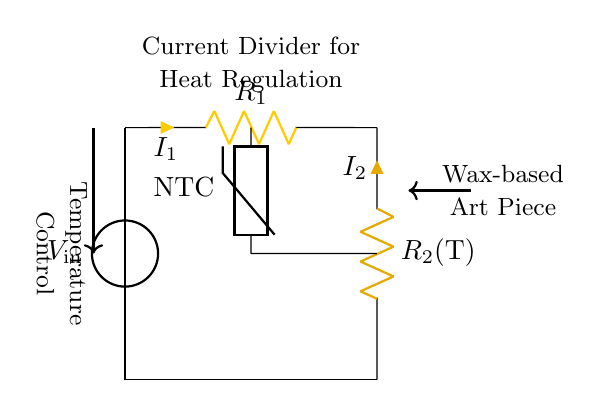What is the input voltage of the circuit? The input voltage can be found at the voltage source labeled as V_in. The voltage value, however, is not specified in the diagram; still, it indicates that V_in is the supply voltage.
Answer: V_in What type of resistor is used as R2? The resistor R2 is labeled with a variable component indicating that it is a thermistor, specifically, an NTC (Negative Temperature Coefficient) thermistor. This type of resistor changes its resistance with temperature changes.
Answer: Thermistor What are the currents flowing through R1 and R2? The currents flowing through R1 and R2 are labeled as I1 and I2, respectively. These currents are indicative of how the input voltage divides across the resistors in the circuit.
Answer: I1 and I2 How does temperature affect the current? In a current divider circuit with a thermistor, as the temperature increases, the resistance of the thermistor decreases, which in turn affects the ratio of currents I1 and I2. This means that changes in temperature will modify the current distribution between the resistors.
Answer: Varies with temperature What is the function of the NTC thermistor in this circuit? The NTC thermistor's function is to control the current distribution based on the temperature affecting the wax-based art piece. The resistance of the thermistor decreases with an increase in temperature, allowing it to regulate the heat effectively.
Answer: Temperature control What is the total current supplied to the circuit? The total current supplied to the circuit is not directly labeled but can be inferred as the sum of the currents I1 and I2. This is because in a current divider, the total current flowing into a node is equal to the sum of the currents flowing out.
Answer: I1 + I2 